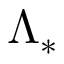<formula> <loc_0><loc_0><loc_500><loc_500>\Lambda _ { \ast }</formula> 